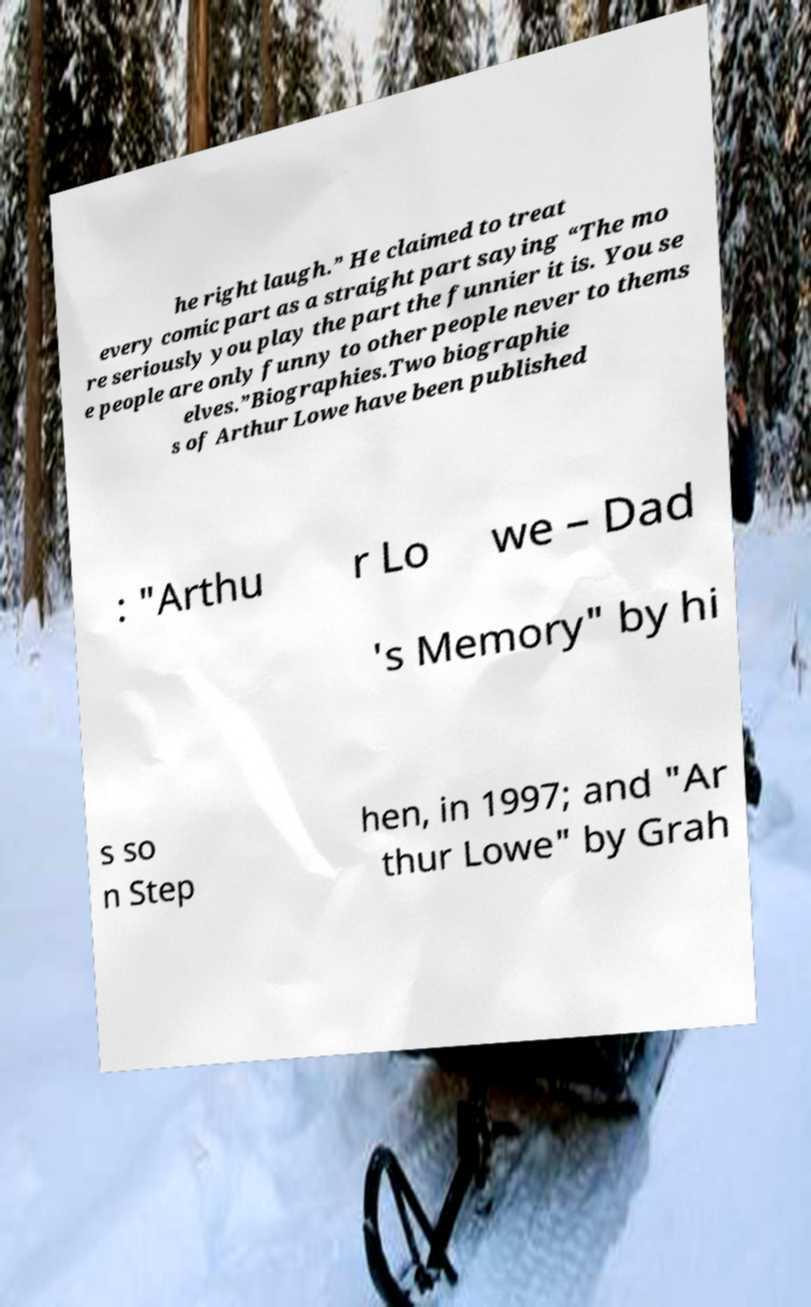For documentation purposes, I need the text within this image transcribed. Could you provide that? he right laugh.” He claimed to treat every comic part as a straight part saying “The mo re seriously you play the part the funnier it is. You se e people are only funny to other people never to thems elves.”Biographies.Two biographie s of Arthur Lowe have been published : "Arthu r Lo we – Dad 's Memory" by hi s so n Step hen, in 1997; and "Ar thur Lowe" by Grah 